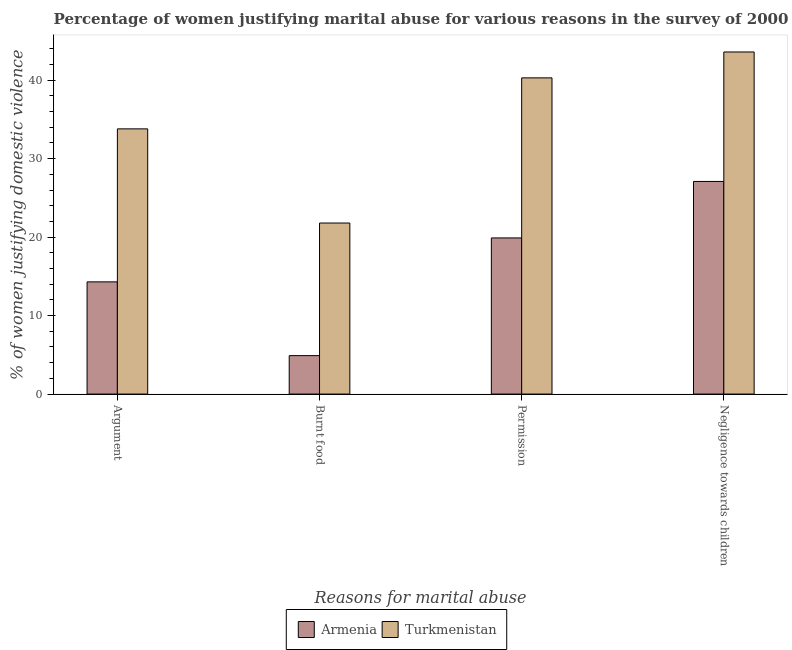How many groups of bars are there?
Offer a terse response. 4. What is the label of the 1st group of bars from the left?
Your response must be concise. Argument. What is the percentage of women justifying abuse for burning food in Armenia?
Ensure brevity in your answer.  4.9. Across all countries, what is the maximum percentage of women justifying abuse for going without permission?
Your answer should be very brief. 40.3. Across all countries, what is the minimum percentage of women justifying abuse in the case of an argument?
Offer a terse response. 14.3. In which country was the percentage of women justifying abuse for going without permission maximum?
Your answer should be very brief. Turkmenistan. In which country was the percentage of women justifying abuse in the case of an argument minimum?
Give a very brief answer. Armenia. What is the total percentage of women justifying abuse for going without permission in the graph?
Provide a succinct answer. 60.2. What is the difference between the percentage of women justifying abuse for burning food in Armenia and that in Turkmenistan?
Your answer should be very brief. -16.9. What is the difference between the percentage of women justifying abuse for burning food in Armenia and the percentage of women justifying abuse for going without permission in Turkmenistan?
Provide a short and direct response. -35.4. What is the average percentage of women justifying abuse for burning food per country?
Ensure brevity in your answer.  13.35. What is the difference between the percentage of women justifying abuse for burning food and percentage of women justifying abuse for going without permission in Armenia?
Offer a terse response. -15. In how many countries, is the percentage of women justifying abuse for burning food greater than 36 %?
Provide a short and direct response. 0. What is the ratio of the percentage of women justifying abuse for burning food in Turkmenistan to that in Armenia?
Your answer should be compact. 4.45. Is the difference between the percentage of women justifying abuse in the case of an argument in Turkmenistan and Armenia greater than the difference between the percentage of women justifying abuse for going without permission in Turkmenistan and Armenia?
Make the answer very short. No. What is the difference between the highest and the second highest percentage of women justifying abuse in the case of an argument?
Ensure brevity in your answer.  19.5. What is the difference between the highest and the lowest percentage of women justifying abuse in the case of an argument?
Keep it short and to the point. 19.5. In how many countries, is the percentage of women justifying abuse for showing negligence towards children greater than the average percentage of women justifying abuse for showing negligence towards children taken over all countries?
Make the answer very short. 1. Is the sum of the percentage of women justifying abuse for showing negligence towards children in Turkmenistan and Armenia greater than the maximum percentage of women justifying abuse for burning food across all countries?
Make the answer very short. Yes. What does the 1st bar from the left in Permission represents?
Keep it short and to the point. Armenia. What does the 2nd bar from the right in Permission represents?
Offer a terse response. Armenia. Is it the case that in every country, the sum of the percentage of women justifying abuse in the case of an argument and percentage of women justifying abuse for burning food is greater than the percentage of women justifying abuse for going without permission?
Your answer should be very brief. No. What is the difference between two consecutive major ticks on the Y-axis?
Provide a short and direct response. 10. Does the graph contain any zero values?
Provide a short and direct response. No. How many legend labels are there?
Provide a succinct answer. 2. What is the title of the graph?
Give a very brief answer. Percentage of women justifying marital abuse for various reasons in the survey of 2000. What is the label or title of the X-axis?
Keep it short and to the point. Reasons for marital abuse. What is the label or title of the Y-axis?
Your answer should be compact. % of women justifying domestic violence. What is the % of women justifying domestic violence of Armenia in Argument?
Give a very brief answer. 14.3. What is the % of women justifying domestic violence in Turkmenistan in Argument?
Make the answer very short. 33.8. What is the % of women justifying domestic violence in Armenia in Burnt food?
Provide a short and direct response. 4.9. What is the % of women justifying domestic violence in Turkmenistan in Burnt food?
Your answer should be very brief. 21.8. What is the % of women justifying domestic violence of Armenia in Permission?
Give a very brief answer. 19.9. What is the % of women justifying domestic violence of Turkmenistan in Permission?
Provide a short and direct response. 40.3. What is the % of women justifying domestic violence of Armenia in Negligence towards children?
Keep it short and to the point. 27.1. What is the % of women justifying domestic violence in Turkmenistan in Negligence towards children?
Make the answer very short. 43.6. Across all Reasons for marital abuse, what is the maximum % of women justifying domestic violence of Armenia?
Keep it short and to the point. 27.1. Across all Reasons for marital abuse, what is the maximum % of women justifying domestic violence in Turkmenistan?
Your response must be concise. 43.6. Across all Reasons for marital abuse, what is the minimum % of women justifying domestic violence of Armenia?
Give a very brief answer. 4.9. Across all Reasons for marital abuse, what is the minimum % of women justifying domestic violence of Turkmenistan?
Offer a very short reply. 21.8. What is the total % of women justifying domestic violence in Armenia in the graph?
Your answer should be very brief. 66.2. What is the total % of women justifying domestic violence of Turkmenistan in the graph?
Offer a very short reply. 139.5. What is the difference between the % of women justifying domestic violence of Armenia in Argument and that in Permission?
Provide a short and direct response. -5.6. What is the difference between the % of women justifying domestic violence of Turkmenistan in Argument and that in Negligence towards children?
Your answer should be compact. -9.8. What is the difference between the % of women justifying domestic violence in Armenia in Burnt food and that in Permission?
Provide a short and direct response. -15. What is the difference between the % of women justifying domestic violence in Turkmenistan in Burnt food and that in Permission?
Offer a terse response. -18.5. What is the difference between the % of women justifying domestic violence of Armenia in Burnt food and that in Negligence towards children?
Your answer should be very brief. -22.2. What is the difference between the % of women justifying domestic violence in Turkmenistan in Burnt food and that in Negligence towards children?
Give a very brief answer. -21.8. What is the difference between the % of women justifying domestic violence of Armenia in Argument and the % of women justifying domestic violence of Turkmenistan in Negligence towards children?
Offer a terse response. -29.3. What is the difference between the % of women justifying domestic violence in Armenia in Burnt food and the % of women justifying domestic violence in Turkmenistan in Permission?
Make the answer very short. -35.4. What is the difference between the % of women justifying domestic violence in Armenia in Burnt food and the % of women justifying domestic violence in Turkmenistan in Negligence towards children?
Offer a very short reply. -38.7. What is the difference between the % of women justifying domestic violence of Armenia in Permission and the % of women justifying domestic violence of Turkmenistan in Negligence towards children?
Your answer should be compact. -23.7. What is the average % of women justifying domestic violence of Armenia per Reasons for marital abuse?
Keep it short and to the point. 16.55. What is the average % of women justifying domestic violence of Turkmenistan per Reasons for marital abuse?
Make the answer very short. 34.88. What is the difference between the % of women justifying domestic violence of Armenia and % of women justifying domestic violence of Turkmenistan in Argument?
Your answer should be compact. -19.5. What is the difference between the % of women justifying domestic violence of Armenia and % of women justifying domestic violence of Turkmenistan in Burnt food?
Ensure brevity in your answer.  -16.9. What is the difference between the % of women justifying domestic violence of Armenia and % of women justifying domestic violence of Turkmenistan in Permission?
Provide a succinct answer. -20.4. What is the difference between the % of women justifying domestic violence in Armenia and % of women justifying domestic violence in Turkmenistan in Negligence towards children?
Offer a terse response. -16.5. What is the ratio of the % of women justifying domestic violence of Armenia in Argument to that in Burnt food?
Provide a short and direct response. 2.92. What is the ratio of the % of women justifying domestic violence in Turkmenistan in Argument to that in Burnt food?
Provide a succinct answer. 1.55. What is the ratio of the % of women justifying domestic violence of Armenia in Argument to that in Permission?
Provide a short and direct response. 0.72. What is the ratio of the % of women justifying domestic violence of Turkmenistan in Argument to that in Permission?
Give a very brief answer. 0.84. What is the ratio of the % of women justifying domestic violence in Armenia in Argument to that in Negligence towards children?
Make the answer very short. 0.53. What is the ratio of the % of women justifying domestic violence of Turkmenistan in Argument to that in Negligence towards children?
Give a very brief answer. 0.78. What is the ratio of the % of women justifying domestic violence of Armenia in Burnt food to that in Permission?
Offer a terse response. 0.25. What is the ratio of the % of women justifying domestic violence of Turkmenistan in Burnt food to that in Permission?
Give a very brief answer. 0.54. What is the ratio of the % of women justifying domestic violence of Armenia in Burnt food to that in Negligence towards children?
Your answer should be compact. 0.18. What is the ratio of the % of women justifying domestic violence in Turkmenistan in Burnt food to that in Negligence towards children?
Keep it short and to the point. 0.5. What is the ratio of the % of women justifying domestic violence of Armenia in Permission to that in Negligence towards children?
Ensure brevity in your answer.  0.73. What is the ratio of the % of women justifying domestic violence in Turkmenistan in Permission to that in Negligence towards children?
Make the answer very short. 0.92. What is the difference between the highest and the second highest % of women justifying domestic violence of Armenia?
Give a very brief answer. 7.2. What is the difference between the highest and the lowest % of women justifying domestic violence in Turkmenistan?
Ensure brevity in your answer.  21.8. 